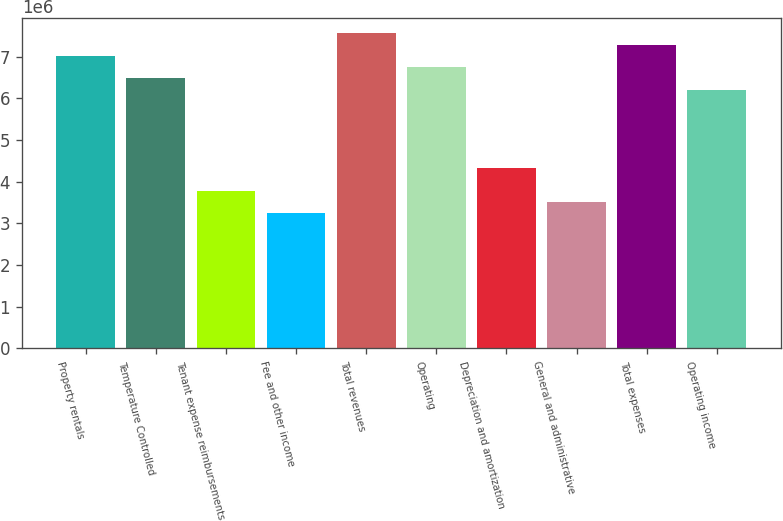Convert chart. <chart><loc_0><loc_0><loc_500><loc_500><bar_chart><fcel>Property rentals<fcel>Temperature Controlled<fcel>Tenant expense reimbursements<fcel>Fee and other income<fcel>Total revenues<fcel>Operating<fcel>Depreciation and amortization<fcel>General and administrative<fcel>Total expenses<fcel>Operating income<nl><fcel>7.0227e+06<fcel>6.48249e+06<fcel>3.78145e+06<fcel>3.24124e+06<fcel>7.5629e+06<fcel>6.75259e+06<fcel>4.32166e+06<fcel>3.51135e+06<fcel>7.2928e+06<fcel>6.21238e+06<nl></chart> 